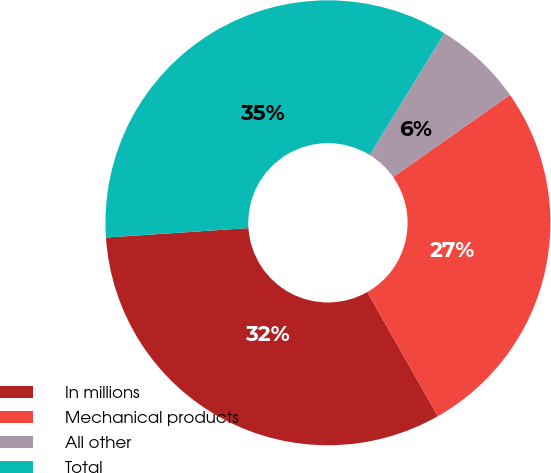<chart> <loc_0><loc_0><loc_500><loc_500><pie_chart><fcel>In millions<fcel>Mechanical products<fcel>All other<fcel>Total<nl><fcel>32.17%<fcel>26.52%<fcel>6.49%<fcel>34.82%<nl></chart> 